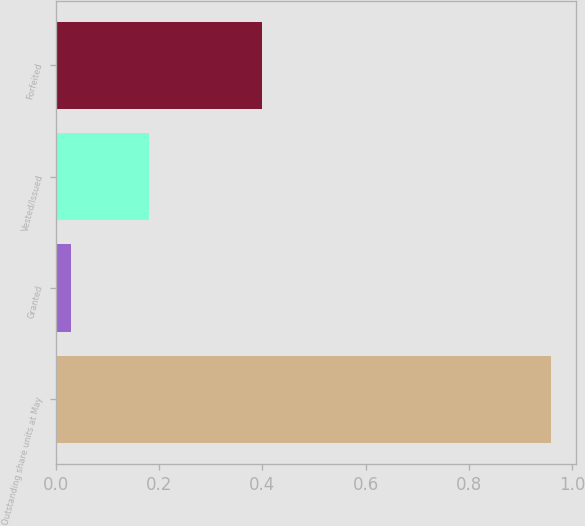Convert chart. <chart><loc_0><loc_0><loc_500><loc_500><bar_chart><fcel>Outstanding share units at May<fcel>Granted<fcel>Vested/Issued<fcel>Forfeited<nl><fcel>0.96<fcel>0.03<fcel>0.18<fcel>0.4<nl></chart> 